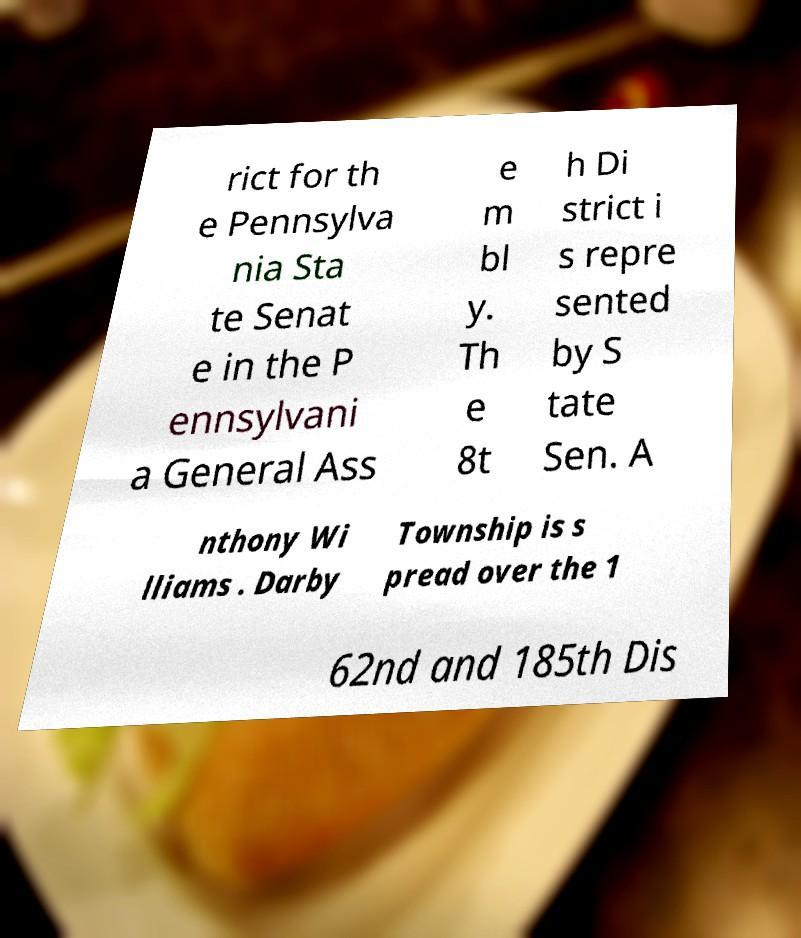Could you extract and type out the text from this image? rict for th e Pennsylva nia Sta te Senat e in the P ennsylvani a General Ass e m bl y. Th e 8t h Di strict i s repre sented by S tate Sen. A nthony Wi lliams . Darby Township is s pread over the 1 62nd and 185th Dis 